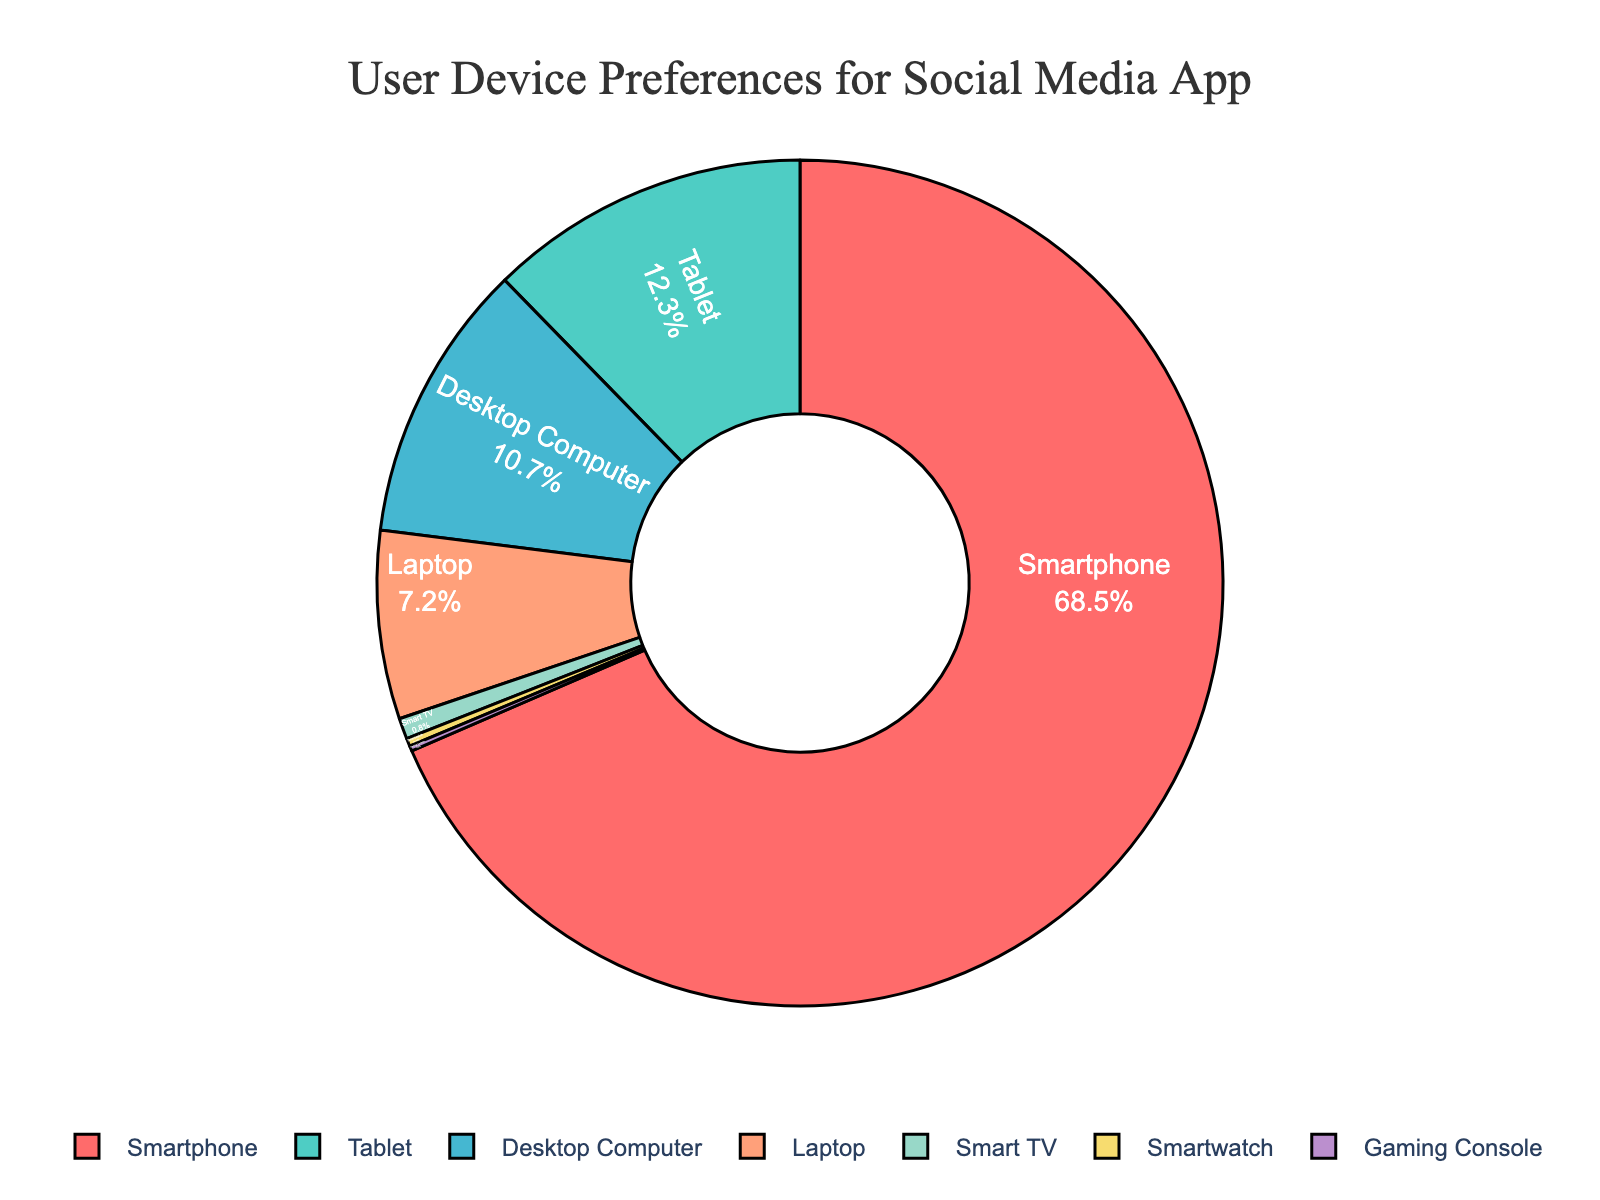Which device type has the highest percentage of users? The figure shows the breakdown of user device preferences with percentages labeled. By looking at the segments, we can see that "Smartphone" has the largest percentage.
Answer: Smartphone What is the combined percentage of users who access the app using a Tablet and a Laptop? To find the combined percentage, add the percentages of "Tablet" and "Laptop." Tablet has 12.3% and Laptop has 7.2%. So, 12.3% + 7.2% = 19.5%.
Answer: 19.5% Is the percentage of Desktop Computer users greater than that of Laptop users? The segment labeled "Desktop Computer" shows 10.7%, while "Laptop" shows 7.2%. Since 10.7% is greater than 7.2%, the percentage of Desktop Computer users is indeed greater.
Answer: Yes By how much does the percentage of Smartphone users exceed the combined percentage of Smart TV, Smartwatch, and Gaming Console users? Smartphone users are 68.5%. The combined percentage for Smart TV, Smartwatch, and Gaming Console is 0.8% + 0.3% + 0.2% = 1.3%. The difference is 68.5% - 1.3% = 67.2%.
Answer: 67.2% Rank the devices from highest to lowest percentage of users. By looking at the segments and their labeled percentages, we list: Smartphone (68.5%), Tablet (12.3%), Desktop Computer (10.7%), Laptop (7.2%), Smart TV (0.8%), Smartwatch (0.3%), Gaming Console (0.2%).
Answer: Smartphone, Tablet, Desktop Computer, Laptop, Smart TV, Smartwatch, Gaming Console What percentage of users access the app using either a Smartphone or a Tablet? Add the percentages of Smartphone and Tablet users: Smartphone (68.5%) + Tablet (12.3%) = 80.8%.
Answer: 80.8% Which device type has the smallest percentage of users? By examining the segments, the "Gaming Console" has the smallest percentage, which is 0.2%.
Answer: Gaming Console How much more percentage of users access the app using a Desktop Computer compared to a Smart TV? Desktop Computer has 10.7% users, while Smart TV has 0.8%. The difference is 10.7% - 0.8% = 9.9%.
Answer: 9.9% What is the average percentage of users for Tablet, Desktop Computer, and Laptop combined? First, sum the percentages: Tablet (12.3%) + Desktop Computer (10.7%) + Laptop (7.2%) = 30.2%. Divide by the number of device types: 30.2% / 3 ≈ 10.07%.
Answer: 10.07% Is the total percentage for Smart TV, Smartwatch, and Gaming Console users greater than 1%? Sum the percentages: Smart TV (0.8%) + Smartwatch (0.3%) + Gaming Console (0.2%) = 1.3%. Since 1.3% > 1%, the total percentage is indeed greater than 1%.
Answer: Yes 